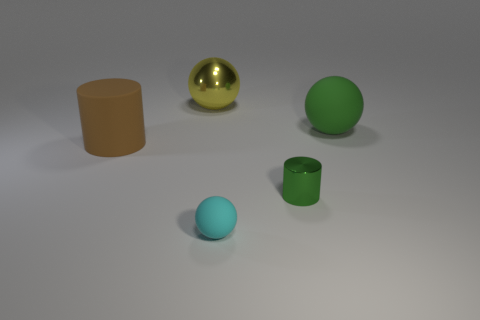There is a green thing behind the big brown matte thing behind the tiny cyan object; what is its material? The green object in the image appears to be a sphere with a matte finish, suggesting that the material could be something like painted wood or hard plastic, given its visual properties and the context of the image. 